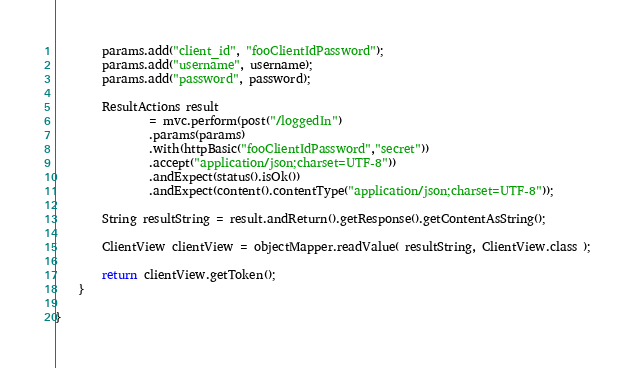Convert code to text. <code><loc_0><loc_0><loc_500><loc_500><_Java_>        params.add("client_id", "fooClientIdPassword");
        params.add("username", username);
        params.add("password", password);

        ResultActions result
                = mvc.perform(post("/loggedIn")
                .params(params)
                .with(httpBasic("fooClientIdPassword","secret"))
                .accept("application/json;charset=UTF-8"))
                .andExpect(status().isOk())
                .andExpect(content().contentType("application/json;charset=UTF-8"));

        String resultString = result.andReturn().getResponse().getContentAsString();

        ClientView clientView = objectMapper.readValue( resultString, ClientView.class );

        return clientView.getToken();
    }

}
</code> 